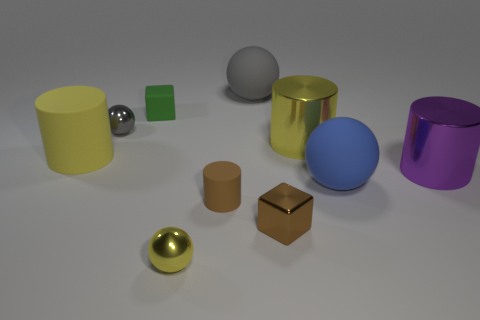Subtract all gray balls. How many were subtracted if there are1gray balls left? 1 Subtract all large yellow matte cylinders. How many cylinders are left? 3 Subtract all balls. How many objects are left? 6 Subtract 4 balls. How many balls are left? 0 Subtract all tiny gray matte cylinders. Subtract all large yellow matte cylinders. How many objects are left? 9 Add 7 large rubber spheres. How many large rubber spheres are left? 9 Add 5 small metal cylinders. How many small metal cylinders exist? 5 Subtract all blue spheres. How many spheres are left? 3 Subtract 0 red blocks. How many objects are left? 10 Subtract all purple cylinders. Subtract all green spheres. How many cylinders are left? 3 